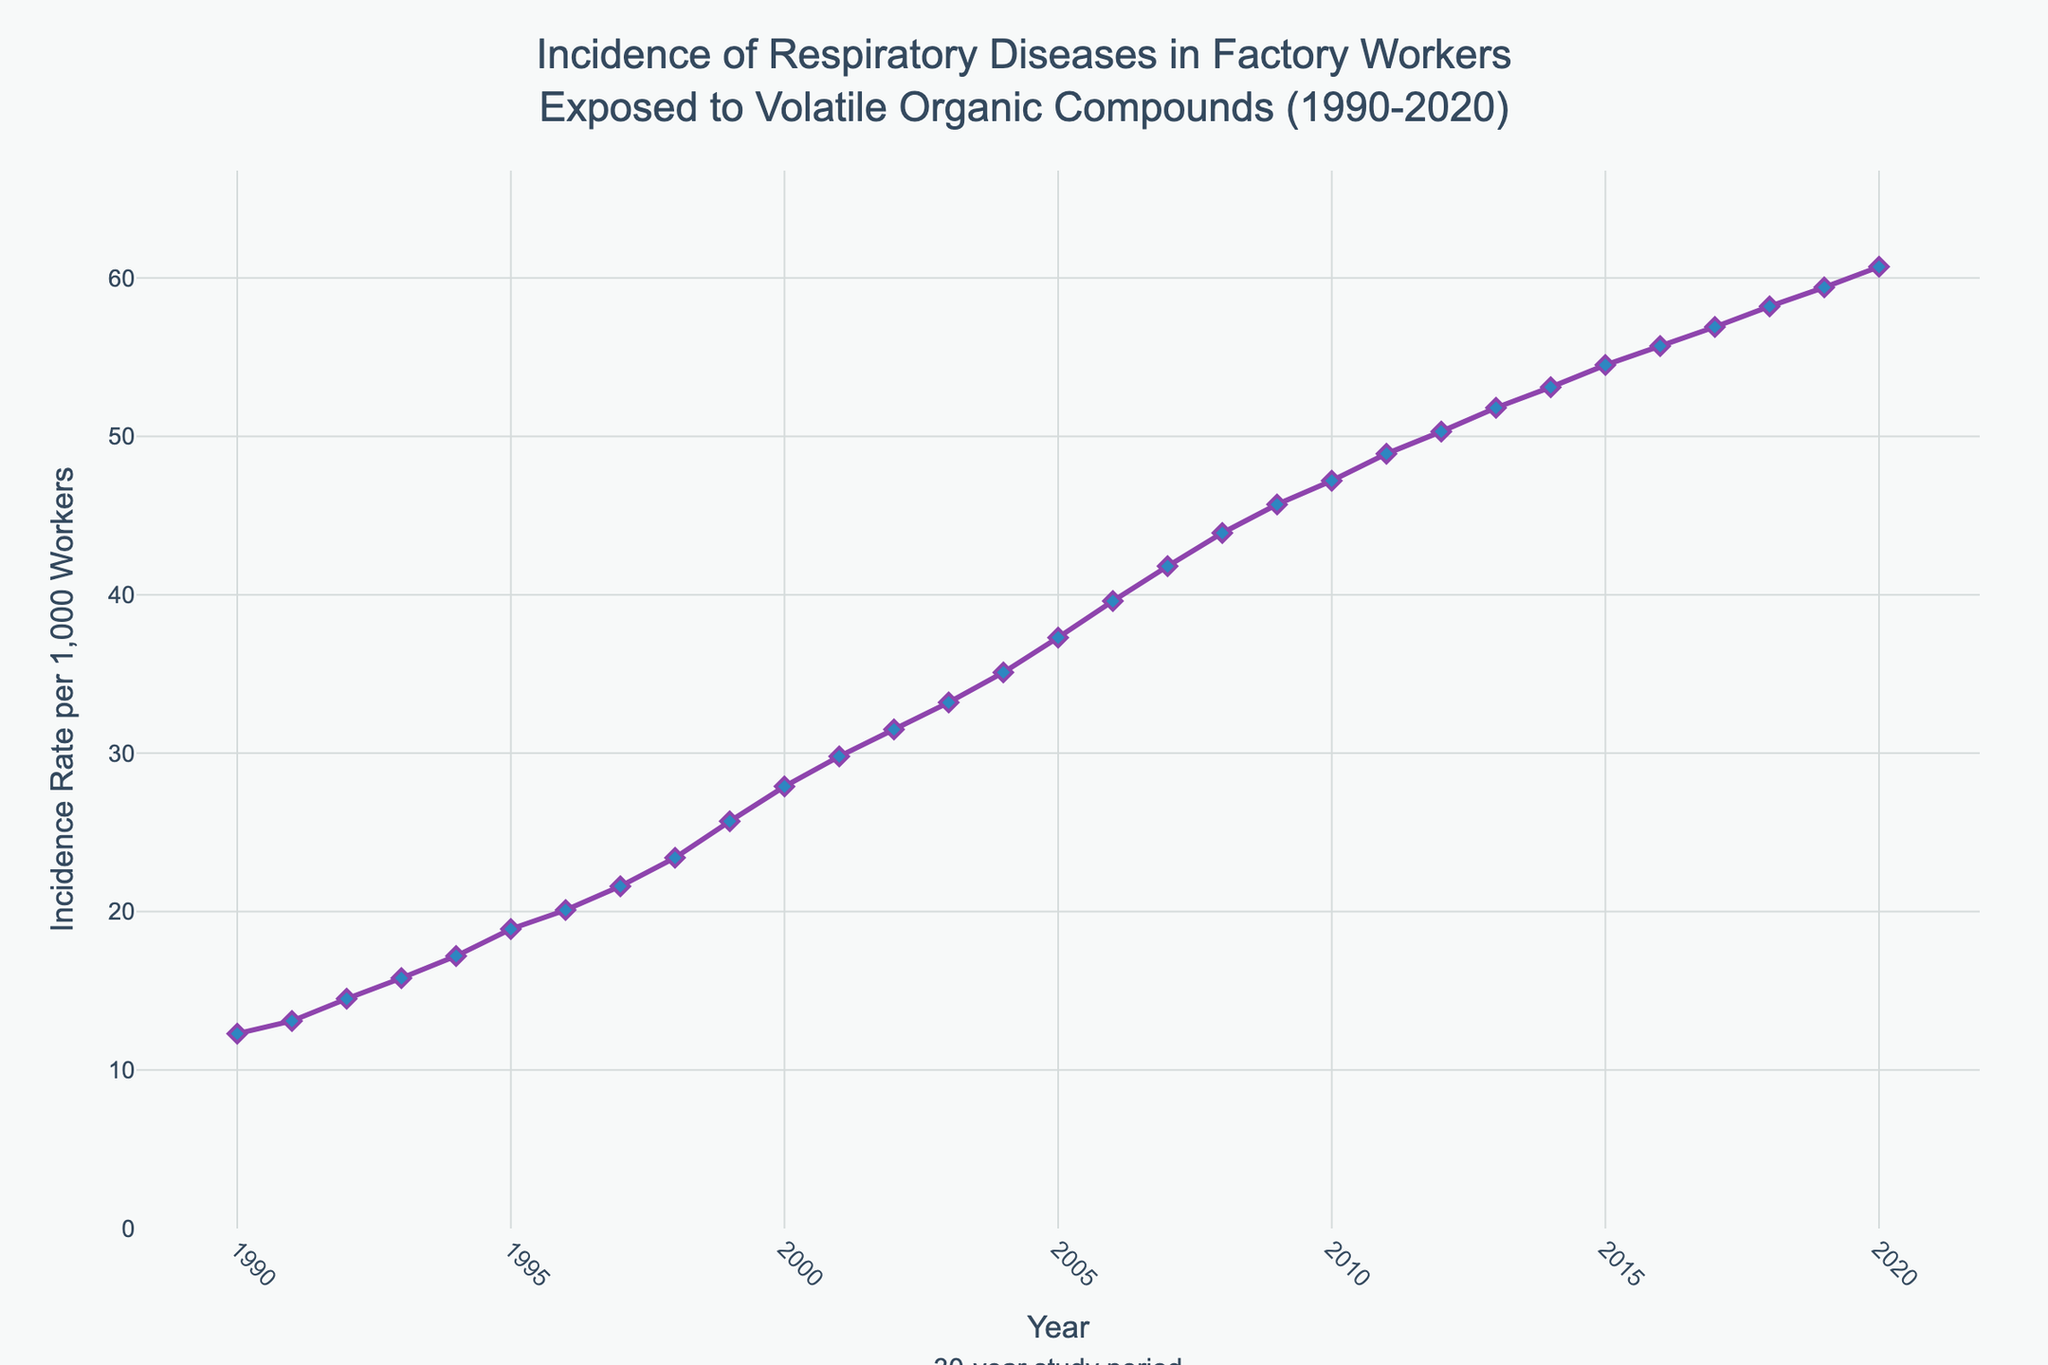What year showed the highest incidence rate of respiratory diseases? The highest point on the line chart corresponds to the year with the highest incidence rate. Here, it is 2020.
Answer: 2020 What is the difference in the incidence rate per 1,000 workers between 1990 and 2020? The incidence rate in 1990 is 12.3, and in 2020 it is 60.7. The difference is 60.7 - 12.3 = 48.4.
Answer: 48.4 What is the average incidence rate per 1,000 workers over the 30-year period? Sum the incidence rates for all years and divide by the total number of years (31 years). The sum is 844.2, so the average is 844.2 / 31 ≈ 27.23.
Answer: 27.23 In which year did the incidence rate first exceed 30 per 1,000 workers? Locate the year in which the incidence rate crosses the 30 mark. This occurs in 2002.
Answer: 2002 Compare the incidence rate in the year 2000 to that in 2010. Which year had a higher incidence rate? In 2000, the incidence rate is 27.9, whereas in 2010 it is 47.2. 2010 has a higher rate.
Answer: 2010 Between which consecutive years did the incidence rate increase the most? Calculate the yearly increments and identify the maximum increase. The largest increase, 2.3, is between 1998 (23.4) and 1999 (25.7).
Answer: 1998 to 1999 What can be said about the trend in the incidence rate over the 30-year period? The incidence rate steadily increases from 12.3 in 1990 to 60.7 in 2020, indicating a continuous upward trend over the 30 years.
Answer: Continuous upward trend What is the rate of increase in incidence per year on average from 1990 to 2020? Subtract the initial rate in 1990 from the final rate in 2020 and divide by the number of years (30). (60.7 - 12.3) / 30 ≈ 1.61.
Answer: 1.61 per year How does the incidence rate in 2005 compare to the average incidence rate over the entire period? The rate in 2005 is 37.3. The average rate is 27.23. Since 37.3 > 27.23, 2005’s rate is higher than the average.
Answer: Higher Identify two years where the incidence rate increased by more than 2 per 1,000 workers from the previous year. Check yearly differences. The incidence increased by 2.3 from 1998 to 1999 and by 2.3 from 2001 to 2002.
Answer: 1998-1999, 2001-2002 